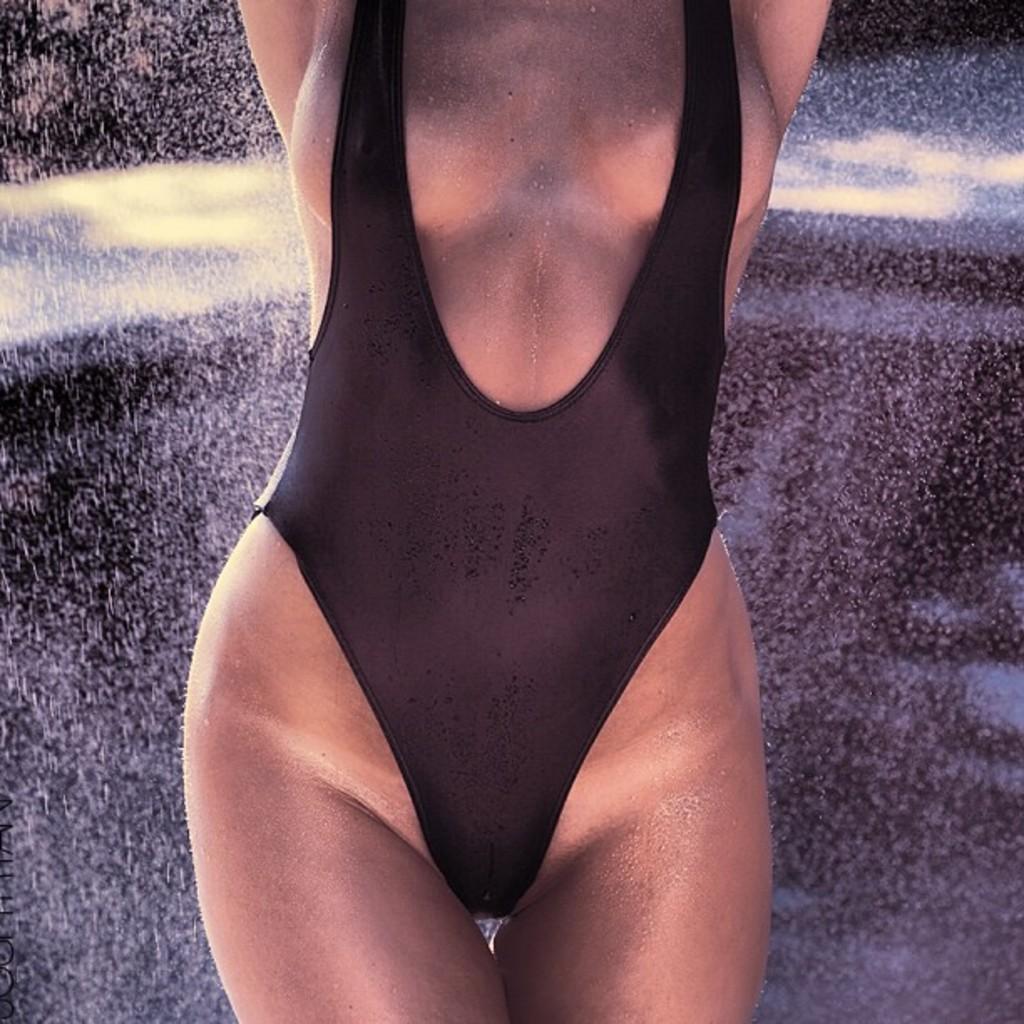How would you summarize this image in a sentence or two? In this picture there is a woman who is wearing black dress. She is standing near to the black wall. 